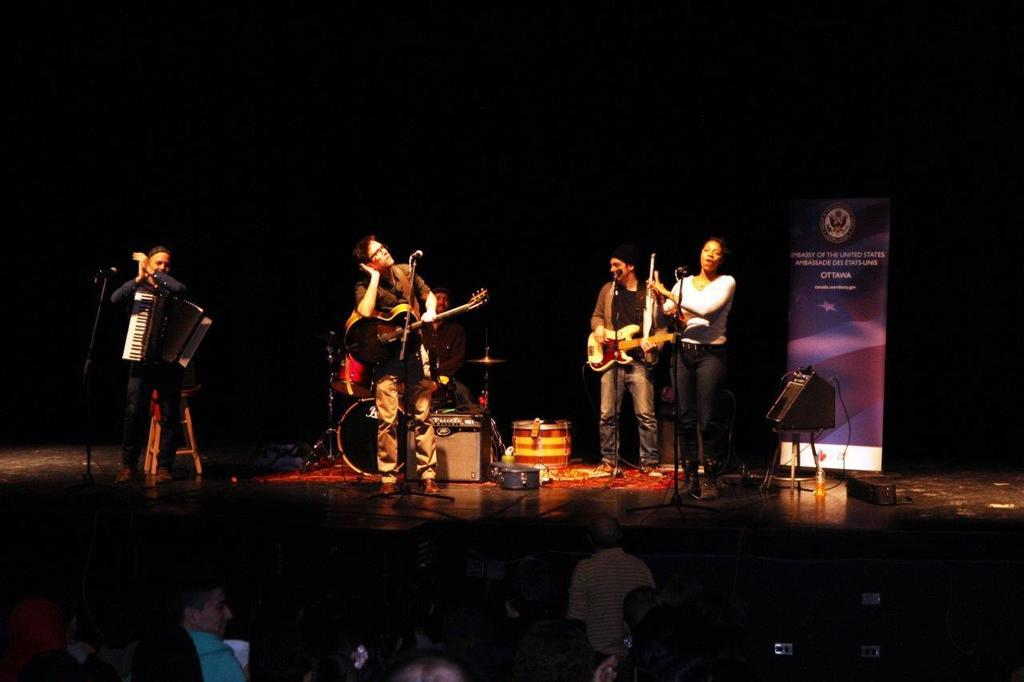What are the people in the image doing? The people in the image are playing musical instruments. Where are the people playing musical instruments located? They are on a dais. Are there any other people visible in the image? Yes, there are other people in the image. What can be seen in the image besides the people and their instruments? There is a speaker in the image. Can you describe any other unspecified things in the image? Unfortunately, the provided facts do not give any details about these unspecified things. Can you see any icicles hanging from the instruments in the image? No, there are no icicles visible in the image. Are there any fish swimming in the background of the image? No, there are no fish present in the image. 